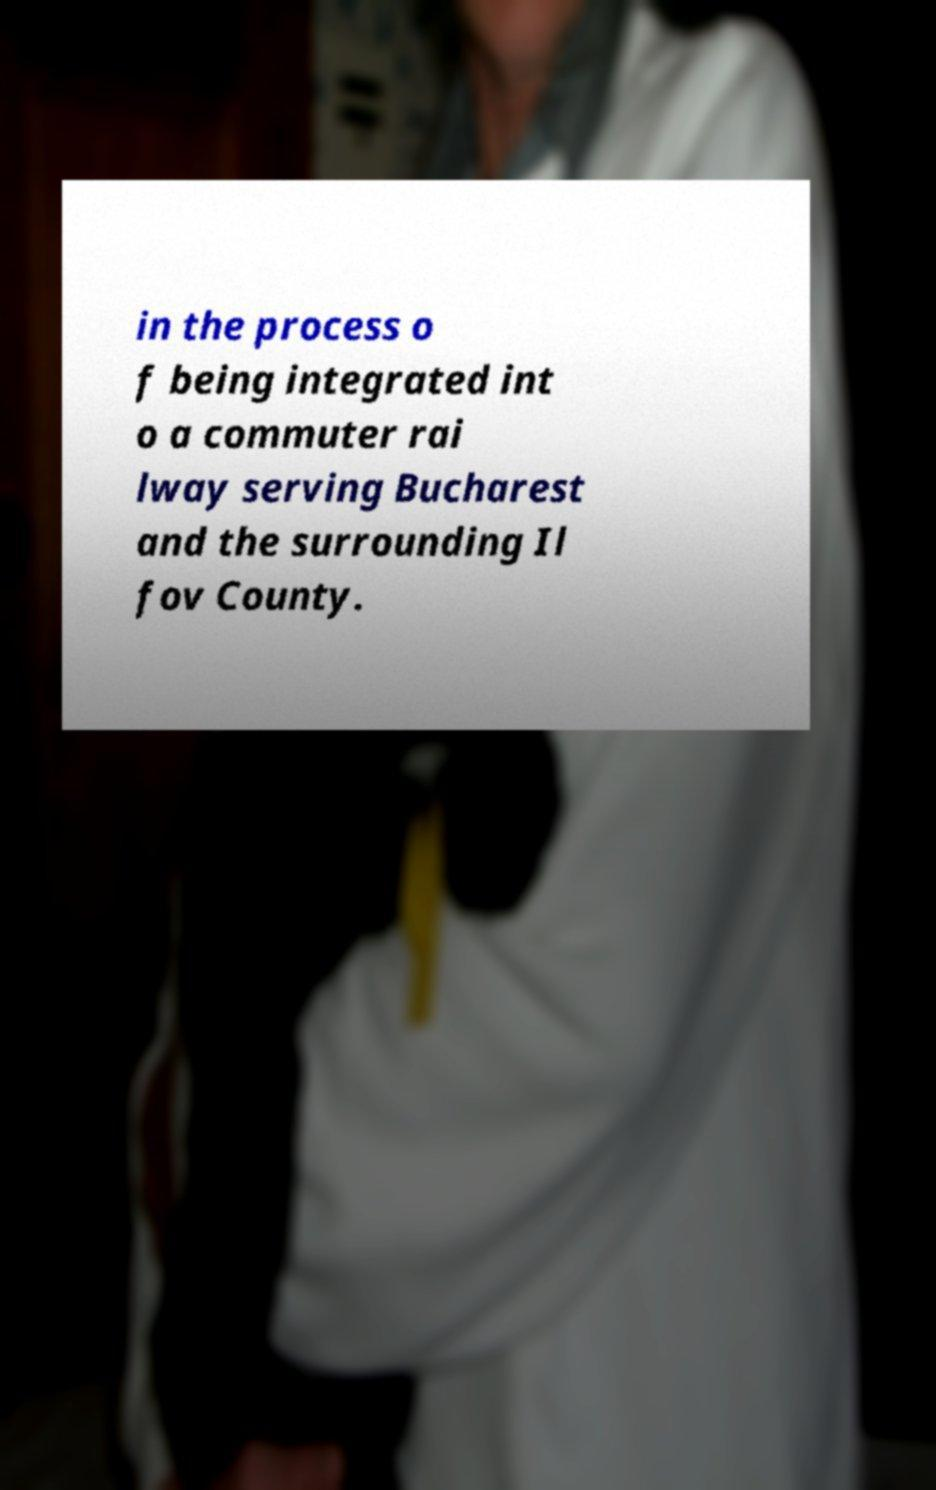Can you read and provide the text displayed in the image?This photo seems to have some interesting text. Can you extract and type it out for me? in the process o f being integrated int o a commuter rai lway serving Bucharest and the surrounding Il fov County. 